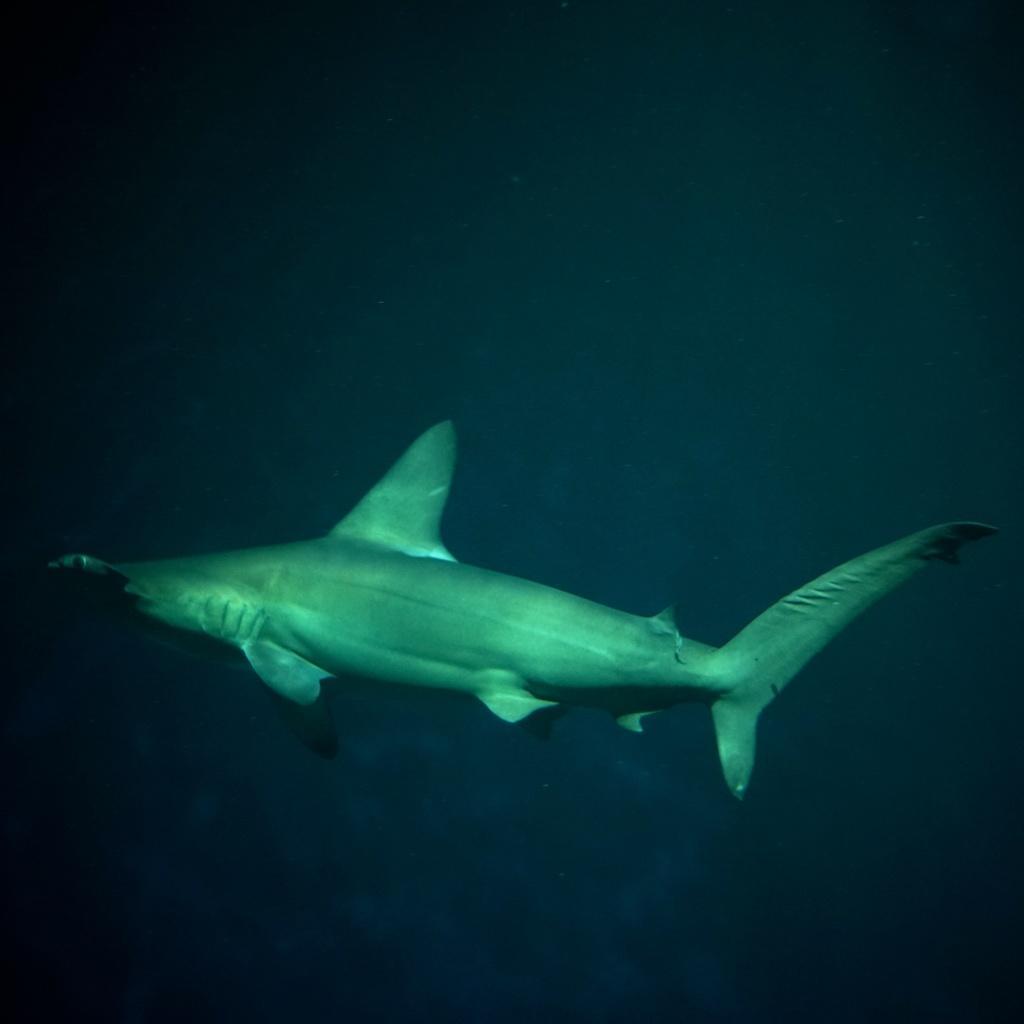Describe this image in one or two sentences. This is a zoomed in picture. In the center we can see a fish seems to be swimming in the water. 